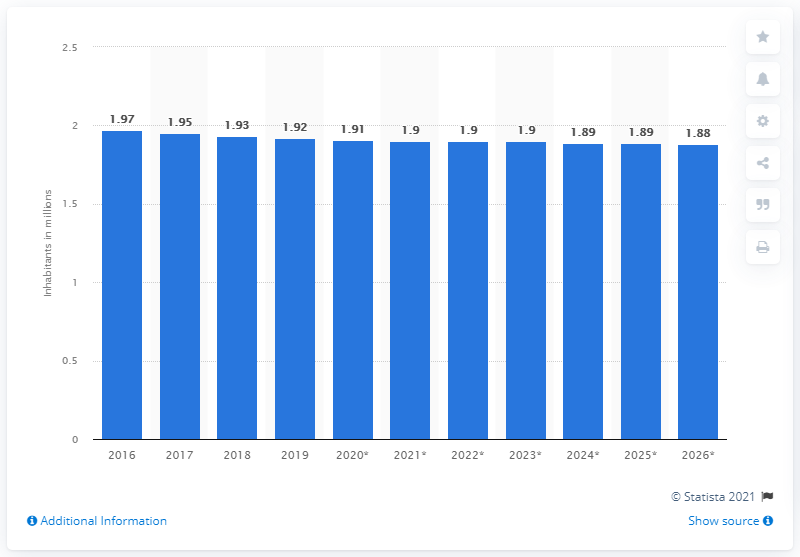Highlight a few significant elements in this photo. In 2019, the population of Latvia was estimated to be approximately 1.91 million. 